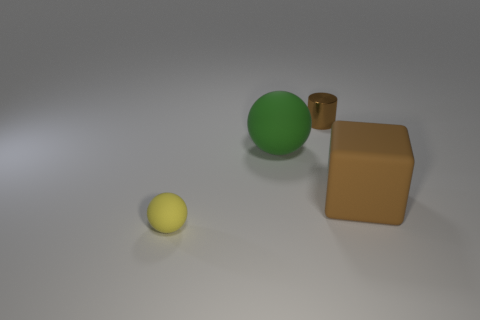Is the number of cyan matte cubes less than the number of large rubber blocks?
Give a very brief answer. Yes. What size is the yellow sphere that is made of the same material as the block?
Make the answer very short. Small. The green thing is what size?
Offer a very short reply. Large. There is a brown metal thing; what shape is it?
Your response must be concise. Cylinder. There is a big matte object to the right of the big green rubber sphere; does it have the same color as the tiny cylinder?
Give a very brief answer. Yes. What size is the other green matte thing that is the same shape as the small rubber object?
Give a very brief answer. Large. Is there any other thing that has the same material as the tiny cylinder?
Ensure brevity in your answer.  No. There is a tiny object to the left of the big thing that is to the left of the big brown block; are there any tiny metallic objects that are in front of it?
Your answer should be very brief. No. What is the material of the brown object that is left of the big brown object?
Your answer should be very brief. Metal. How many small things are either balls or purple cylinders?
Give a very brief answer. 1. 